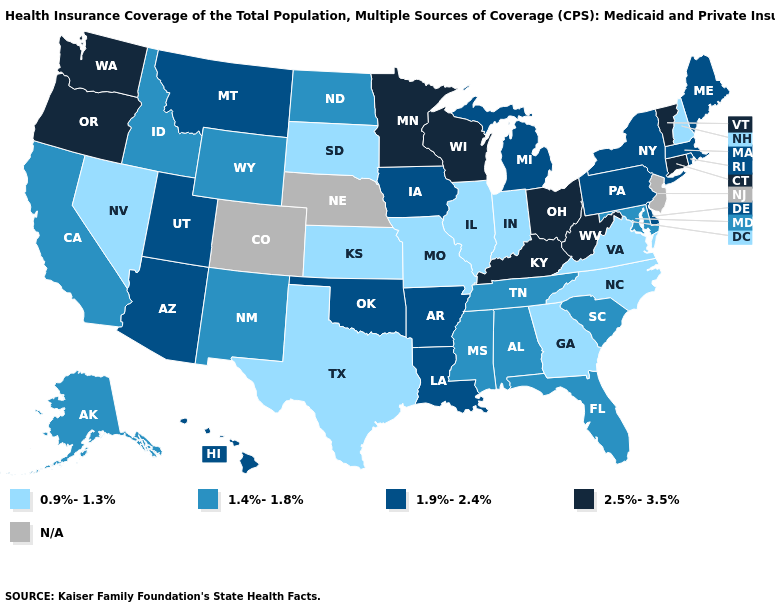What is the lowest value in the USA?
Concise answer only. 0.9%-1.3%. Does the map have missing data?
Answer briefly. Yes. Name the states that have a value in the range 2.5%-3.5%?
Short answer required. Connecticut, Kentucky, Minnesota, Ohio, Oregon, Vermont, Washington, West Virginia, Wisconsin. What is the highest value in the West ?
Be succinct. 2.5%-3.5%. What is the lowest value in the USA?
Concise answer only. 0.9%-1.3%. Name the states that have a value in the range 0.9%-1.3%?
Answer briefly. Georgia, Illinois, Indiana, Kansas, Missouri, Nevada, New Hampshire, North Carolina, South Dakota, Texas, Virginia. What is the lowest value in the USA?
Be succinct. 0.9%-1.3%. Does Hawaii have the highest value in the USA?
Short answer required. No. What is the lowest value in the West?
Keep it brief. 0.9%-1.3%. Name the states that have a value in the range 1.4%-1.8%?
Write a very short answer. Alabama, Alaska, California, Florida, Idaho, Maryland, Mississippi, New Mexico, North Dakota, South Carolina, Tennessee, Wyoming. What is the value of Oregon?
Answer briefly. 2.5%-3.5%. What is the highest value in states that border South Carolina?
Short answer required. 0.9%-1.3%. 